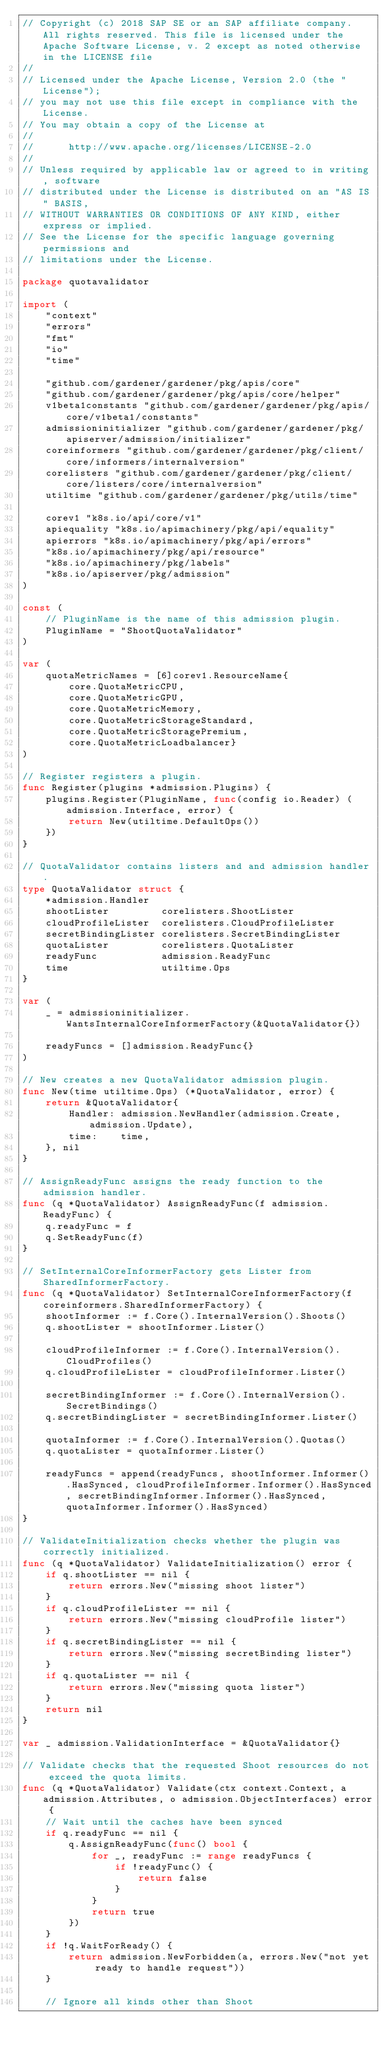Convert code to text. <code><loc_0><loc_0><loc_500><loc_500><_Go_>// Copyright (c) 2018 SAP SE or an SAP affiliate company. All rights reserved. This file is licensed under the Apache Software License, v. 2 except as noted otherwise in the LICENSE file
//
// Licensed under the Apache License, Version 2.0 (the "License");
// you may not use this file except in compliance with the License.
// You may obtain a copy of the License at
//
//      http://www.apache.org/licenses/LICENSE-2.0
//
// Unless required by applicable law or agreed to in writing, software
// distributed under the License is distributed on an "AS IS" BASIS,
// WITHOUT WARRANTIES OR CONDITIONS OF ANY KIND, either express or implied.
// See the License for the specific language governing permissions and
// limitations under the License.

package quotavalidator

import (
	"context"
	"errors"
	"fmt"
	"io"
	"time"

	"github.com/gardener/gardener/pkg/apis/core"
	"github.com/gardener/gardener/pkg/apis/core/helper"
	v1beta1constants "github.com/gardener/gardener/pkg/apis/core/v1beta1/constants"
	admissioninitializer "github.com/gardener/gardener/pkg/apiserver/admission/initializer"
	coreinformers "github.com/gardener/gardener/pkg/client/core/informers/internalversion"
	corelisters "github.com/gardener/gardener/pkg/client/core/listers/core/internalversion"
	utiltime "github.com/gardener/gardener/pkg/utils/time"

	corev1 "k8s.io/api/core/v1"
	apiequality "k8s.io/apimachinery/pkg/api/equality"
	apierrors "k8s.io/apimachinery/pkg/api/errors"
	"k8s.io/apimachinery/pkg/api/resource"
	"k8s.io/apimachinery/pkg/labels"
	"k8s.io/apiserver/pkg/admission"
)

const (
	// PluginName is the name of this admission plugin.
	PluginName = "ShootQuotaValidator"
)

var (
	quotaMetricNames = [6]corev1.ResourceName{
		core.QuotaMetricCPU,
		core.QuotaMetricGPU,
		core.QuotaMetricMemory,
		core.QuotaMetricStorageStandard,
		core.QuotaMetricStoragePremium,
		core.QuotaMetricLoadbalancer}
)

// Register registers a plugin.
func Register(plugins *admission.Plugins) {
	plugins.Register(PluginName, func(config io.Reader) (admission.Interface, error) {
		return New(utiltime.DefaultOps())
	})
}

// QuotaValidator contains listers and and admission handler.
type QuotaValidator struct {
	*admission.Handler
	shootLister         corelisters.ShootLister
	cloudProfileLister  corelisters.CloudProfileLister
	secretBindingLister corelisters.SecretBindingLister
	quotaLister         corelisters.QuotaLister
	readyFunc           admission.ReadyFunc
	time                utiltime.Ops
}

var (
	_ = admissioninitializer.WantsInternalCoreInformerFactory(&QuotaValidator{})

	readyFuncs = []admission.ReadyFunc{}
)

// New creates a new QuotaValidator admission plugin.
func New(time utiltime.Ops) (*QuotaValidator, error) {
	return &QuotaValidator{
		Handler: admission.NewHandler(admission.Create, admission.Update),
		time:    time,
	}, nil
}

// AssignReadyFunc assigns the ready function to the admission handler.
func (q *QuotaValidator) AssignReadyFunc(f admission.ReadyFunc) {
	q.readyFunc = f
	q.SetReadyFunc(f)
}

// SetInternalCoreInformerFactory gets Lister from SharedInformerFactory.
func (q *QuotaValidator) SetInternalCoreInformerFactory(f coreinformers.SharedInformerFactory) {
	shootInformer := f.Core().InternalVersion().Shoots()
	q.shootLister = shootInformer.Lister()

	cloudProfileInformer := f.Core().InternalVersion().CloudProfiles()
	q.cloudProfileLister = cloudProfileInformer.Lister()

	secretBindingInformer := f.Core().InternalVersion().SecretBindings()
	q.secretBindingLister = secretBindingInformer.Lister()

	quotaInformer := f.Core().InternalVersion().Quotas()
	q.quotaLister = quotaInformer.Lister()

	readyFuncs = append(readyFuncs, shootInformer.Informer().HasSynced, cloudProfileInformer.Informer().HasSynced, secretBindingInformer.Informer().HasSynced, quotaInformer.Informer().HasSynced)
}

// ValidateInitialization checks whether the plugin was correctly initialized.
func (q *QuotaValidator) ValidateInitialization() error {
	if q.shootLister == nil {
		return errors.New("missing shoot lister")
	}
	if q.cloudProfileLister == nil {
		return errors.New("missing cloudProfile lister")
	}
	if q.secretBindingLister == nil {
		return errors.New("missing secretBinding lister")
	}
	if q.quotaLister == nil {
		return errors.New("missing quota lister")
	}
	return nil
}

var _ admission.ValidationInterface = &QuotaValidator{}

// Validate checks that the requested Shoot resources do not exceed the quota limits.
func (q *QuotaValidator) Validate(ctx context.Context, a admission.Attributes, o admission.ObjectInterfaces) error {
	// Wait until the caches have been synced
	if q.readyFunc == nil {
		q.AssignReadyFunc(func() bool {
			for _, readyFunc := range readyFuncs {
				if !readyFunc() {
					return false
				}
			}
			return true
		})
	}
	if !q.WaitForReady() {
		return admission.NewForbidden(a, errors.New("not yet ready to handle request"))
	}

	// Ignore all kinds other than Shoot</code> 